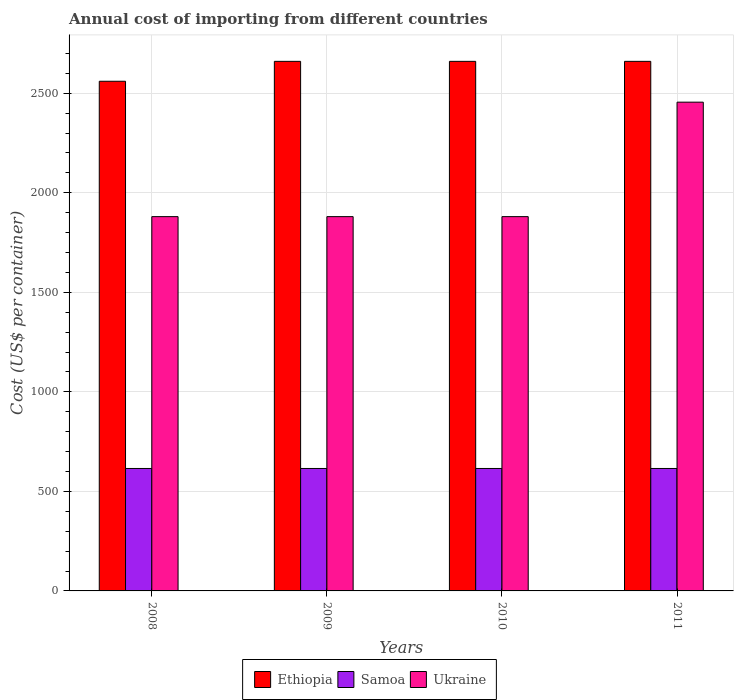Are the number of bars per tick equal to the number of legend labels?
Your answer should be very brief. Yes. How many bars are there on the 3rd tick from the left?
Provide a succinct answer. 3. In how many cases, is the number of bars for a given year not equal to the number of legend labels?
Your answer should be compact. 0. What is the total annual cost of importing in Ethiopia in 2008?
Ensure brevity in your answer.  2560. Across all years, what is the maximum total annual cost of importing in Samoa?
Ensure brevity in your answer.  615. Across all years, what is the minimum total annual cost of importing in Ukraine?
Keep it short and to the point. 1880. In which year was the total annual cost of importing in Ukraine maximum?
Provide a short and direct response. 2011. What is the total total annual cost of importing in Ukraine in the graph?
Your response must be concise. 8095. What is the difference between the total annual cost of importing in Samoa in 2008 and that in 2010?
Provide a short and direct response. 0. What is the difference between the total annual cost of importing in Ethiopia in 2008 and the total annual cost of importing in Samoa in 2010?
Keep it short and to the point. 1945. What is the average total annual cost of importing in Ukraine per year?
Ensure brevity in your answer.  2023.75. In the year 2010, what is the difference between the total annual cost of importing in Samoa and total annual cost of importing in Ethiopia?
Give a very brief answer. -2045. In how many years, is the total annual cost of importing in Samoa greater than 2200 US$?
Offer a very short reply. 0. What is the ratio of the total annual cost of importing in Ukraine in 2008 to that in 2010?
Give a very brief answer. 1. Is the total annual cost of importing in Ukraine in 2010 less than that in 2011?
Provide a short and direct response. Yes. What is the difference between the highest and the second highest total annual cost of importing in Samoa?
Keep it short and to the point. 0. What is the difference between the highest and the lowest total annual cost of importing in Ethiopia?
Provide a short and direct response. 100. In how many years, is the total annual cost of importing in Ethiopia greater than the average total annual cost of importing in Ethiopia taken over all years?
Make the answer very short. 3. What does the 2nd bar from the left in 2008 represents?
Offer a very short reply. Samoa. What does the 3rd bar from the right in 2011 represents?
Offer a very short reply. Ethiopia. How many bars are there?
Your answer should be very brief. 12. Are all the bars in the graph horizontal?
Make the answer very short. No. Are the values on the major ticks of Y-axis written in scientific E-notation?
Offer a terse response. No. Does the graph contain any zero values?
Your answer should be compact. No. What is the title of the graph?
Keep it short and to the point. Annual cost of importing from different countries. Does "Aruba" appear as one of the legend labels in the graph?
Your answer should be compact. No. What is the label or title of the Y-axis?
Provide a short and direct response. Cost (US$ per container). What is the Cost (US$ per container) in Ethiopia in 2008?
Provide a short and direct response. 2560. What is the Cost (US$ per container) of Samoa in 2008?
Ensure brevity in your answer.  615. What is the Cost (US$ per container) of Ukraine in 2008?
Your response must be concise. 1880. What is the Cost (US$ per container) in Ethiopia in 2009?
Your answer should be compact. 2660. What is the Cost (US$ per container) of Samoa in 2009?
Provide a short and direct response. 615. What is the Cost (US$ per container) of Ukraine in 2009?
Offer a terse response. 1880. What is the Cost (US$ per container) of Ethiopia in 2010?
Make the answer very short. 2660. What is the Cost (US$ per container) of Samoa in 2010?
Provide a succinct answer. 615. What is the Cost (US$ per container) of Ukraine in 2010?
Offer a terse response. 1880. What is the Cost (US$ per container) of Ethiopia in 2011?
Your answer should be compact. 2660. What is the Cost (US$ per container) in Samoa in 2011?
Keep it short and to the point. 615. What is the Cost (US$ per container) of Ukraine in 2011?
Keep it short and to the point. 2455. Across all years, what is the maximum Cost (US$ per container) in Ethiopia?
Your answer should be compact. 2660. Across all years, what is the maximum Cost (US$ per container) of Samoa?
Your answer should be compact. 615. Across all years, what is the maximum Cost (US$ per container) of Ukraine?
Provide a short and direct response. 2455. Across all years, what is the minimum Cost (US$ per container) of Ethiopia?
Your answer should be very brief. 2560. Across all years, what is the minimum Cost (US$ per container) in Samoa?
Keep it short and to the point. 615. Across all years, what is the minimum Cost (US$ per container) in Ukraine?
Provide a short and direct response. 1880. What is the total Cost (US$ per container) in Ethiopia in the graph?
Provide a short and direct response. 1.05e+04. What is the total Cost (US$ per container) of Samoa in the graph?
Your response must be concise. 2460. What is the total Cost (US$ per container) of Ukraine in the graph?
Your answer should be very brief. 8095. What is the difference between the Cost (US$ per container) of Ethiopia in 2008 and that in 2009?
Make the answer very short. -100. What is the difference between the Cost (US$ per container) in Samoa in 2008 and that in 2009?
Make the answer very short. 0. What is the difference between the Cost (US$ per container) of Ethiopia in 2008 and that in 2010?
Ensure brevity in your answer.  -100. What is the difference between the Cost (US$ per container) of Samoa in 2008 and that in 2010?
Your response must be concise. 0. What is the difference between the Cost (US$ per container) in Ethiopia in 2008 and that in 2011?
Make the answer very short. -100. What is the difference between the Cost (US$ per container) of Samoa in 2008 and that in 2011?
Make the answer very short. 0. What is the difference between the Cost (US$ per container) of Ukraine in 2008 and that in 2011?
Offer a very short reply. -575. What is the difference between the Cost (US$ per container) in Ethiopia in 2009 and that in 2010?
Offer a very short reply. 0. What is the difference between the Cost (US$ per container) in Samoa in 2009 and that in 2010?
Your response must be concise. 0. What is the difference between the Cost (US$ per container) of Ethiopia in 2009 and that in 2011?
Make the answer very short. 0. What is the difference between the Cost (US$ per container) in Samoa in 2009 and that in 2011?
Offer a terse response. 0. What is the difference between the Cost (US$ per container) of Ukraine in 2009 and that in 2011?
Keep it short and to the point. -575. What is the difference between the Cost (US$ per container) in Samoa in 2010 and that in 2011?
Provide a succinct answer. 0. What is the difference between the Cost (US$ per container) of Ukraine in 2010 and that in 2011?
Your answer should be very brief. -575. What is the difference between the Cost (US$ per container) of Ethiopia in 2008 and the Cost (US$ per container) of Samoa in 2009?
Keep it short and to the point. 1945. What is the difference between the Cost (US$ per container) in Ethiopia in 2008 and the Cost (US$ per container) in Ukraine in 2009?
Provide a short and direct response. 680. What is the difference between the Cost (US$ per container) in Samoa in 2008 and the Cost (US$ per container) in Ukraine in 2009?
Your answer should be compact. -1265. What is the difference between the Cost (US$ per container) of Ethiopia in 2008 and the Cost (US$ per container) of Samoa in 2010?
Your answer should be very brief. 1945. What is the difference between the Cost (US$ per container) of Ethiopia in 2008 and the Cost (US$ per container) of Ukraine in 2010?
Offer a very short reply. 680. What is the difference between the Cost (US$ per container) of Samoa in 2008 and the Cost (US$ per container) of Ukraine in 2010?
Ensure brevity in your answer.  -1265. What is the difference between the Cost (US$ per container) of Ethiopia in 2008 and the Cost (US$ per container) of Samoa in 2011?
Provide a short and direct response. 1945. What is the difference between the Cost (US$ per container) of Ethiopia in 2008 and the Cost (US$ per container) of Ukraine in 2011?
Give a very brief answer. 105. What is the difference between the Cost (US$ per container) in Samoa in 2008 and the Cost (US$ per container) in Ukraine in 2011?
Your response must be concise. -1840. What is the difference between the Cost (US$ per container) of Ethiopia in 2009 and the Cost (US$ per container) of Samoa in 2010?
Ensure brevity in your answer.  2045. What is the difference between the Cost (US$ per container) in Ethiopia in 2009 and the Cost (US$ per container) in Ukraine in 2010?
Your answer should be compact. 780. What is the difference between the Cost (US$ per container) of Samoa in 2009 and the Cost (US$ per container) of Ukraine in 2010?
Your response must be concise. -1265. What is the difference between the Cost (US$ per container) of Ethiopia in 2009 and the Cost (US$ per container) of Samoa in 2011?
Make the answer very short. 2045. What is the difference between the Cost (US$ per container) in Ethiopia in 2009 and the Cost (US$ per container) in Ukraine in 2011?
Give a very brief answer. 205. What is the difference between the Cost (US$ per container) of Samoa in 2009 and the Cost (US$ per container) of Ukraine in 2011?
Your answer should be compact. -1840. What is the difference between the Cost (US$ per container) in Ethiopia in 2010 and the Cost (US$ per container) in Samoa in 2011?
Offer a very short reply. 2045. What is the difference between the Cost (US$ per container) in Ethiopia in 2010 and the Cost (US$ per container) in Ukraine in 2011?
Make the answer very short. 205. What is the difference between the Cost (US$ per container) in Samoa in 2010 and the Cost (US$ per container) in Ukraine in 2011?
Provide a succinct answer. -1840. What is the average Cost (US$ per container) of Ethiopia per year?
Give a very brief answer. 2635. What is the average Cost (US$ per container) of Samoa per year?
Offer a terse response. 615. What is the average Cost (US$ per container) in Ukraine per year?
Offer a very short reply. 2023.75. In the year 2008, what is the difference between the Cost (US$ per container) of Ethiopia and Cost (US$ per container) of Samoa?
Your answer should be very brief. 1945. In the year 2008, what is the difference between the Cost (US$ per container) in Ethiopia and Cost (US$ per container) in Ukraine?
Your answer should be compact. 680. In the year 2008, what is the difference between the Cost (US$ per container) of Samoa and Cost (US$ per container) of Ukraine?
Your answer should be very brief. -1265. In the year 2009, what is the difference between the Cost (US$ per container) of Ethiopia and Cost (US$ per container) of Samoa?
Your answer should be compact. 2045. In the year 2009, what is the difference between the Cost (US$ per container) of Ethiopia and Cost (US$ per container) of Ukraine?
Your answer should be compact. 780. In the year 2009, what is the difference between the Cost (US$ per container) in Samoa and Cost (US$ per container) in Ukraine?
Provide a short and direct response. -1265. In the year 2010, what is the difference between the Cost (US$ per container) in Ethiopia and Cost (US$ per container) in Samoa?
Your answer should be very brief. 2045. In the year 2010, what is the difference between the Cost (US$ per container) of Ethiopia and Cost (US$ per container) of Ukraine?
Keep it short and to the point. 780. In the year 2010, what is the difference between the Cost (US$ per container) in Samoa and Cost (US$ per container) in Ukraine?
Offer a very short reply. -1265. In the year 2011, what is the difference between the Cost (US$ per container) of Ethiopia and Cost (US$ per container) of Samoa?
Offer a terse response. 2045. In the year 2011, what is the difference between the Cost (US$ per container) of Ethiopia and Cost (US$ per container) of Ukraine?
Provide a short and direct response. 205. In the year 2011, what is the difference between the Cost (US$ per container) in Samoa and Cost (US$ per container) in Ukraine?
Provide a succinct answer. -1840. What is the ratio of the Cost (US$ per container) in Ethiopia in 2008 to that in 2009?
Your answer should be compact. 0.96. What is the ratio of the Cost (US$ per container) in Ukraine in 2008 to that in 2009?
Provide a short and direct response. 1. What is the ratio of the Cost (US$ per container) in Ethiopia in 2008 to that in 2010?
Ensure brevity in your answer.  0.96. What is the ratio of the Cost (US$ per container) in Ethiopia in 2008 to that in 2011?
Offer a terse response. 0.96. What is the ratio of the Cost (US$ per container) of Samoa in 2008 to that in 2011?
Provide a short and direct response. 1. What is the ratio of the Cost (US$ per container) of Ukraine in 2008 to that in 2011?
Your answer should be compact. 0.77. What is the ratio of the Cost (US$ per container) in Samoa in 2009 to that in 2010?
Offer a very short reply. 1. What is the ratio of the Cost (US$ per container) of Ethiopia in 2009 to that in 2011?
Offer a terse response. 1. What is the ratio of the Cost (US$ per container) of Samoa in 2009 to that in 2011?
Offer a terse response. 1. What is the ratio of the Cost (US$ per container) in Ukraine in 2009 to that in 2011?
Provide a succinct answer. 0.77. What is the ratio of the Cost (US$ per container) in Samoa in 2010 to that in 2011?
Keep it short and to the point. 1. What is the ratio of the Cost (US$ per container) in Ukraine in 2010 to that in 2011?
Provide a short and direct response. 0.77. What is the difference between the highest and the second highest Cost (US$ per container) of Ethiopia?
Your answer should be compact. 0. What is the difference between the highest and the second highest Cost (US$ per container) in Samoa?
Ensure brevity in your answer.  0. What is the difference between the highest and the second highest Cost (US$ per container) of Ukraine?
Offer a very short reply. 575. What is the difference between the highest and the lowest Cost (US$ per container) in Ethiopia?
Make the answer very short. 100. What is the difference between the highest and the lowest Cost (US$ per container) of Samoa?
Your answer should be compact. 0. What is the difference between the highest and the lowest Cost (US$ per container) in Ukraine?
Your response must be concise. 575. 